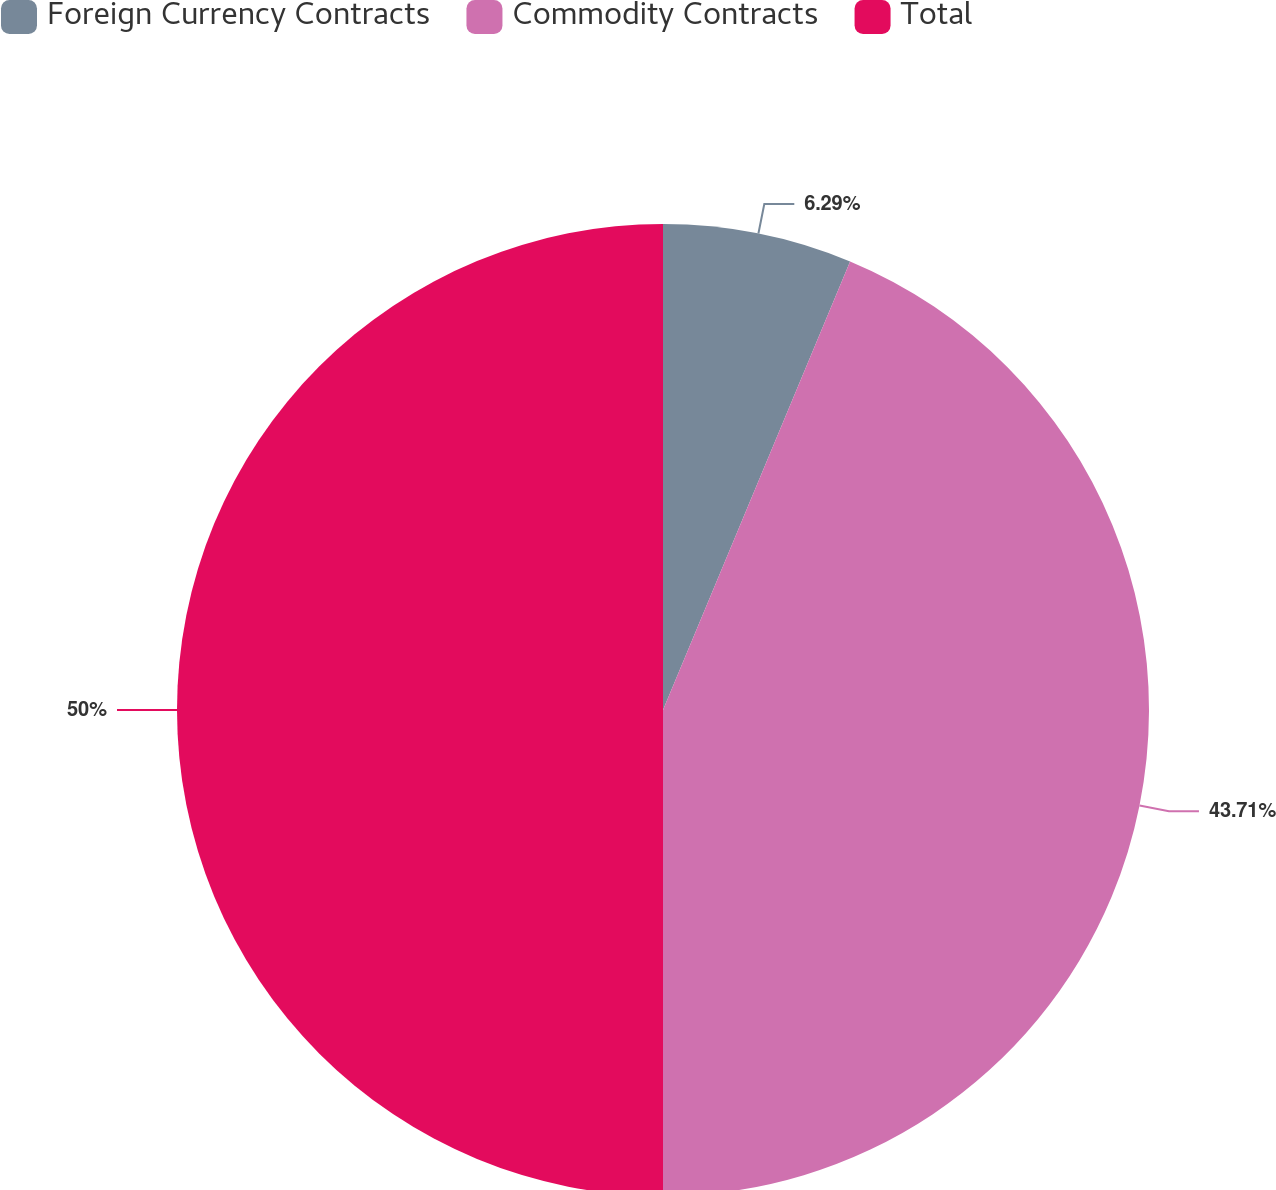Convert chart to OTSL. <chart><loc_0><loc_0><loc_500><loc_500><pie_chart><fcel>Foreign Currency Contracts<fcel>Commodity Contracts<fcel>Total<nl><fcel>6.29%<fcel>43.71%<fcel>50.0%<nl></chart> 